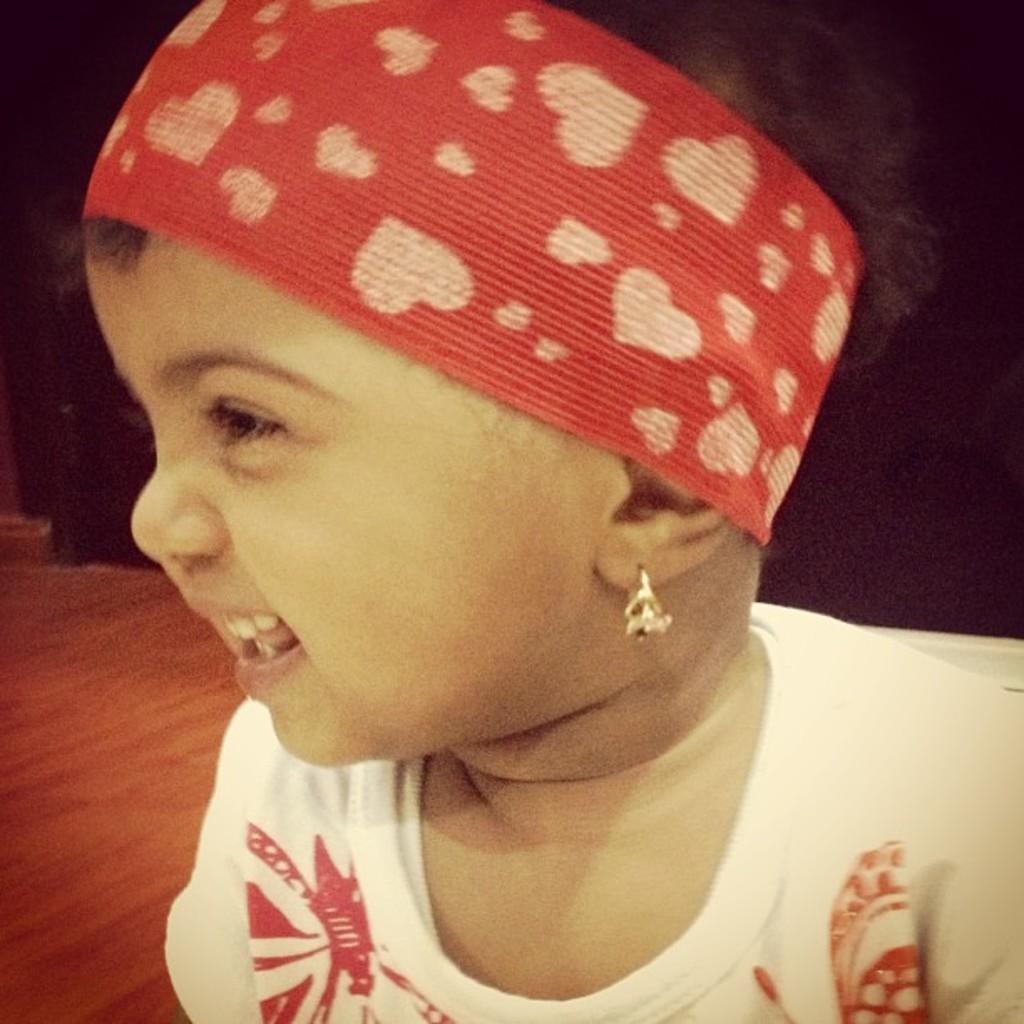Could you give a brief overview of what you see in this image? In this picture I can see a child in front who is wearing white color t-shirt and I see a head band on the head and on the band I can see the hearts. In the background I can see the brown color surface and I see that it is a bit dark. 